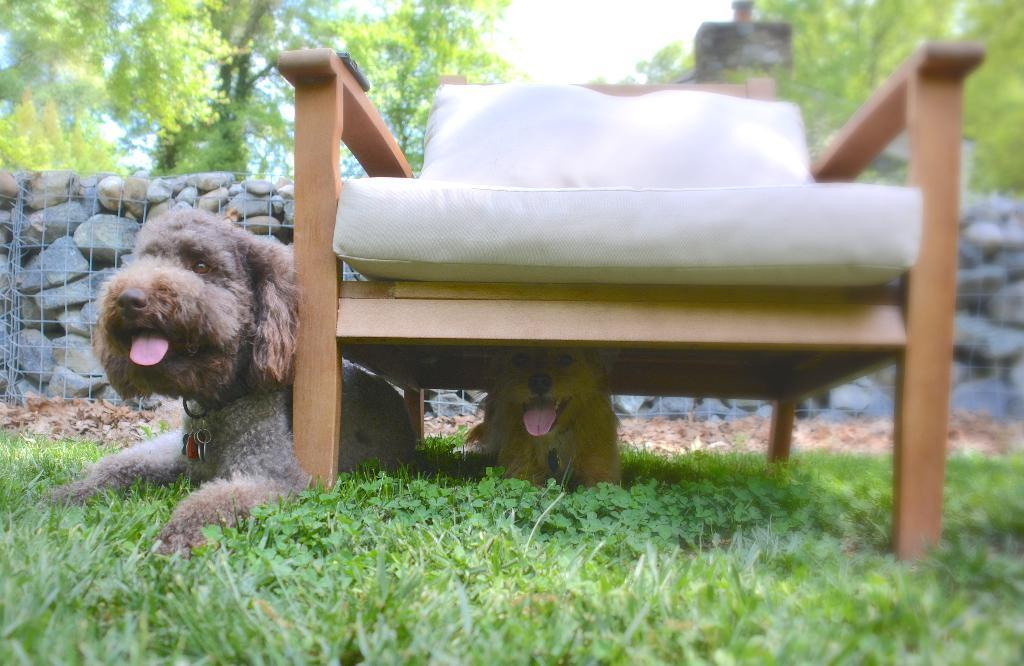How many dogs are in the image? There are two dogs in the image. Where is one of the dogs located? One dog is under a chair. What is the surface the dogs are sitting on? The dogs are sitting on the grass. What can be seen in the background of the image? There are stones and trees visible in the background of the image. What type of stamp can be seen on the dog's collar in the image? There is no stamp visible on the dog's collar in the image, as the dogs are not wearing collars. 